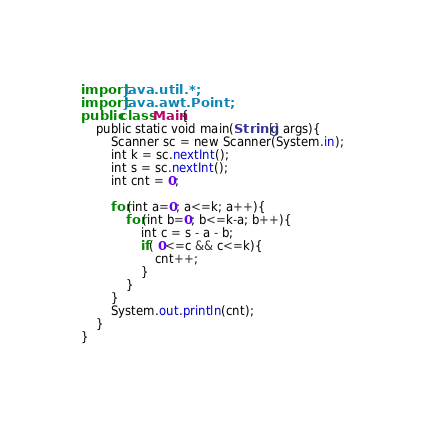<code> <loc_0><loc_0><loc_500><loc_500><_Kotlin_>import java.util.*;
import java.awt.Point;
public class Main{
	public static void main(String[] args){
        Scanner sc = new Scanner(System.in);
        int k = sc.nextInt();
        int s = sc.nextInt();
        int cnt = 0;

        for(int a=0; a<=k; a++){
            for(int b=0; b<=k-a; b++){
                int c = s - a - b;
                if( 0<=c && c<=k){
                    cnt++;
                }        
            }
        }
        System.out.println(cnt);
    }
}</code> 